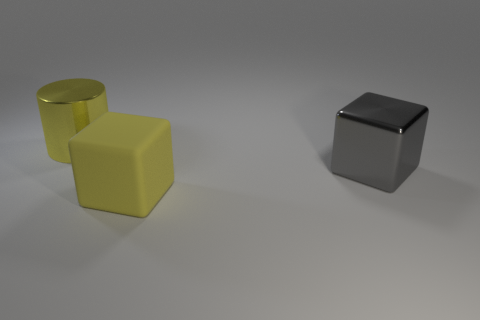There is a gray object; what shape is it?
Keep it short and to the point. Cube. How many tiny cyan shiny cubes are there?
Keep it short and to the point. 0. What is the color of the large thing that is behind the big metal object on the right side of the metallic cylinder?
Your answer should be compact. Yellow. What is the color of the metallic block that is the same size as the yellow rubber block?
Make the answer very short. Gray. Is there another big cylinder that has the same color as the cylinder?
Offer a very short reply. No. Are any green metallic balls visible?
Provide a succinct answer. No. The large metal thing behind the large gray metal block has what shape?
Ensure brevity in your answer.  Cylinder. What number of big shiny objects are in front of the large cylinder and left of the gray cube?
Make the answer very short. 0. What number of other objects are the same size as the yellow rubber thing?
Make the answer very short. 2. There is a yellow thing that is behind the yellow block; is it the same shape as the big thing that is in front of the gray object?
Offer a terse response. No. 